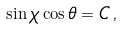<formula> <loc_0><loc_0><loc_500><loc_500>\sin \chi \cos \theta = C \, ,</formula> 